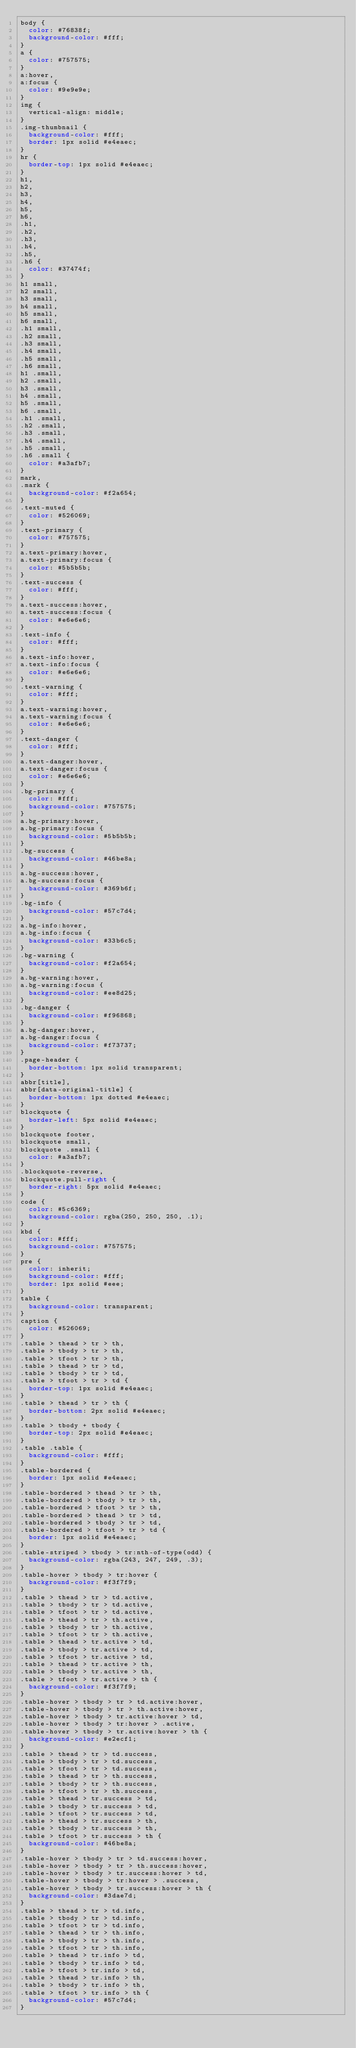<code> <loc_0><loc_0><loc_500><loc_500><_CSS_>body {
  color: #76838f;
  background-color: #fff;
}
a {
  color: #757575;
}
a:hover,
a:focus {
  color: #9e9e9e;
}
img {
  vertical-align: middle;
}
.img-thumbnail {
  background-color: #fff;
  border: 1px solid #e4eaec;
}
hr {
  border-top: 1px solid #e4eaec;
}
h1,
h2,
h3,
h4,
h5,
h6,
.h1,
.h2,
.h3,
.h4,
.h5,
.h6 {
  color: #37474f;
}
h1 small,
h2 small,
h3 small,
h4 small,
h5 small,
h6 small,
.h1 small,
.h2 small,
.h3 small,
.h4 small,
.h5 small,
.h6 small,
h1 .small,
h2 .small,
h3 .small,
h4 .small,
h5 .small,
h6 .small,
.h1 .small,
.h2 .small,
.h3 .small,
.h4 .small,
.h5 .small,
.h6 .small {
  color: #a3afb7;
}
mark,
.mark {
  background-color: #f2a654;
}
.text-muted {
  color: #526069;
}
.text-primary {
  color: #757575;
}
a.text-primary:hover,
a.text-primary:focus {
  color: #5b5b5b;
}
.text-success {
  color: #fff;
}
a.text-success:hover,
a.text-success:focus {
  color: #e6e6e6;
}
.text-info {
  color: #fff;
}
a.text-info:hover,
a.text-info:focus {
  color: #e6e6e6;
}
.text-warning {
  color: #fff;
}
a.text-warning:hover,
a.text-warning:focus {
  color: #e6e6e6;
}
.text-danger {
  color: #fff;
}
a.text-danger:hover,
a.text-danger:focus {
  color: #e6e6e6;
}
.bg-primary {
  color: #fff;
  background-color: #757575;
}
a.bg-primary:hover,
a.bg-primary:focus {
  background-color: #5b5b5b;
}
.bg-success {
  background-color: #46be8a;
}
a.bg-success:hover,
a.bg-success:focus {
  background-color: #369b6f;
}
.bg-info {
  background-color: #57c7d4;
}
a.bg-info:hover,
a.bg-info:focus {
  background-color: #33b6c5;
}
.bg-warning {
  background-color: #f2a654;
}
a.bg-warning:hover,
a.bg-warning:focus {
  background-color: #ee8d25;
}
.bg-danger {
  background-color: #f96868;
}
a.bg-danger:hover,
a.bg-danger:focus {
  background-color: #f73737;
}
.page-header {
  border-bottom: 1px solid transparent;
}
abbr[title],
abbr[data-original-title] {
  border-bottom: 1px dotted #e4eaec;
}
blockquote {
  border-left: 5px solid #e4eaec;
}
blockquote footer,
blockquote small,
blockquote .small {
  color: #a3afb7;
}
.blockquote-reverse,
blockquote.pull-right {
  border-right: 5px solid #e4eaec;
}
code {
  color: #5c6369;
  background-color: rgba(250, 250, 250, .1);
}
kbd {
  color: #fff;
  background-color: #757575;
}
pre {
  color: inherit;
  background-color: #fff;
  border: 1px solid #eee;
}
table {
  background-color: transparent;
}
caption {
  color: #526069;
}
.table > thead > tr > th,
.table > tbody > tr > th,
.table > tfoot > tr > th,
.table > thead > tr > td,
.table > tbody > tr > td,
.table > tfoot > tr > td {
  border-top: 1px solid #e4eaec;
}
.table > thead > tr > th {
  border-bottom: 2px solid #e4eaec;
}
.table > tbody + tbody {
  border-top: 2px solid #e4eaec;
}
.table .table {
  background-color: #fff;
}
.table-bordered {
  border: 1px solid #e4eaec;
}
.table-bordered > thead > tr > th,
.table-bordered > tbody > tr > th,
.table-bordered > tfoot > tr > th,
.table-bordered > thead > tr > td,
.table-bordered > tbody > tr > td,
.table-bordered > tfoot > tr > td {
  border: 1px solid #e4eaec;
}
.table-striped > tbody > tr:nth-of-type(odd) {
  background-color: rgba(243, 247, 249, .3);
}
.table-hover > tbody > tr:hover {
  background-color: #f3f7f9;
}
.table > thead > tr > td.active,
.table > tbody > tr > td.active,
.table > tfoot > tr > td.active,
.table > thead > tr > th.active,
.table > tbody > tr > th.active,
.table > tfoot > tr > th.active,
.table > thead > tr.active > td,
.table > tbody > tr.active > td,
.table > tfoot > tr.active > td,
.table > thead > tr.active > th,
.table > tbody > tr.active > th,
.table > tfoot > tr.active > th {
  background-color: #f3f7f9;
}
.table-hover > tbody > tr > td.active:hover,
.table-hover > tbody > tr > th.active:hover,
.table-hover > tbody > tr.active:hover > td,
.table-hover > tbody > tr:hover > .active,
.table-hover > tbody > tr.active:hover > th {
  background-color: #e2ecf1;
}
.table > thead > tr > td.success,
.table > tbody > tr > td.success,
.table > tfoot > tr > td.success,
.table > thead > tr > th.success,
.table > tbody > tr > th.success,
.table > tfoot > tr > th.success,
.table > thead > tr.success > td,
.table > tbody > tr.success > td,
.table > tfoot > tr.success > td,
.table > thead > tr.success > th,
.table > tbody > tr.success > th,
.table > tfoot > tr.success > th {
  background-color: #46be8a;
}
.table-hover > tbody > tr > td.success:hover,
.table-hover > tbody > tr > th.success:hover,
.table-hover > tbody > tr.success:hover > td,
.table-hover > tbody > tr:hover > .success,
.table-hover > tbody > tr.success:hover > th {
  background-color: #3dae7d;
}
.table > thead > tr > td.info,
.table > tbody > tr > td.info,
.table > tfoot > tr > td.info,
.table > thead > tr > th.info,
.table > tbody > tr > th.info,
.table > tfoot > tr > th.info,
.table > thead > tr.info > td,
.table > tbody > tr.info > td,
.table > tfoot > tr.info > td,
.table > thead > tr.info > th,
.table > tbody > tr.info > th,
.table > tfoot > tr.info > th {
  background-color: #57c7d4;
}</code> 